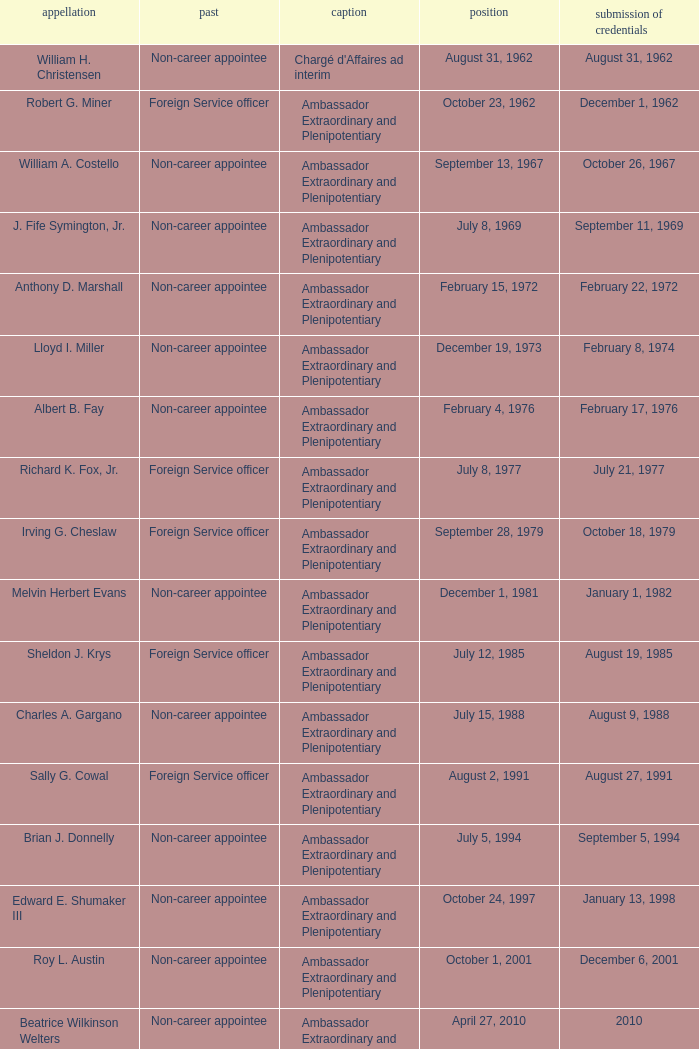When was William A. Costello appointed? September 13, 1967. 